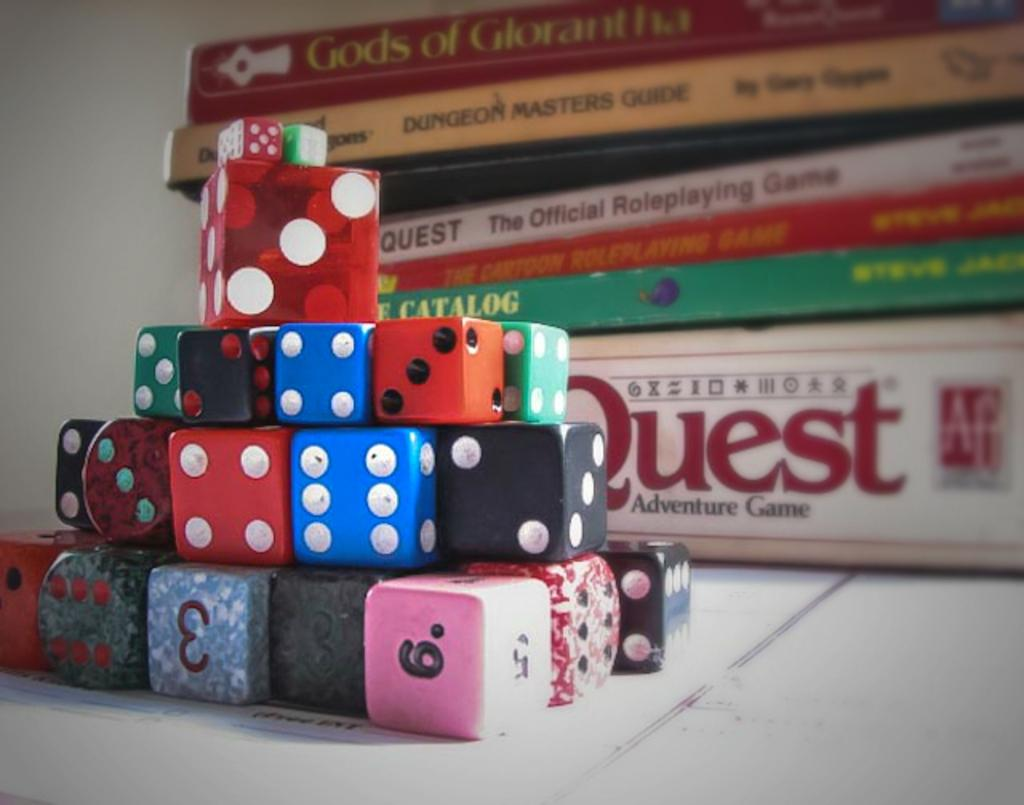<image>
Present a compact description of the photo's key features. A stack of dice sit on font of books with one titled Quest. 